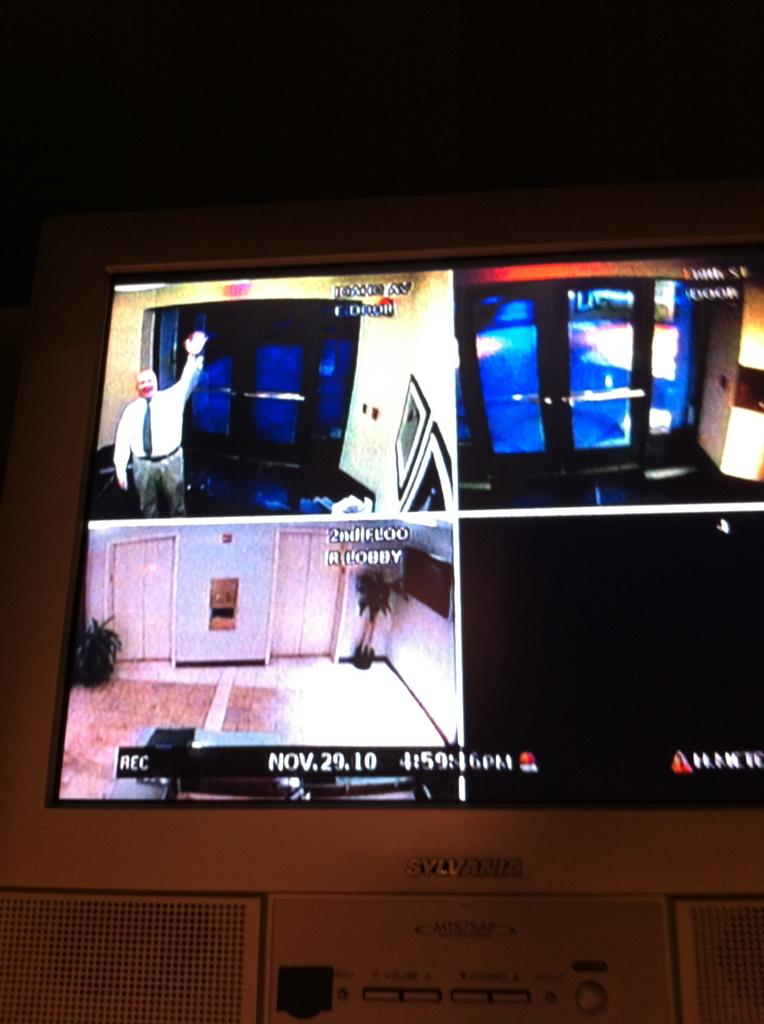<image>
Summarize the visual content of the image. A Sylvania monitor with various camera images from Nov. 29, 2010. 